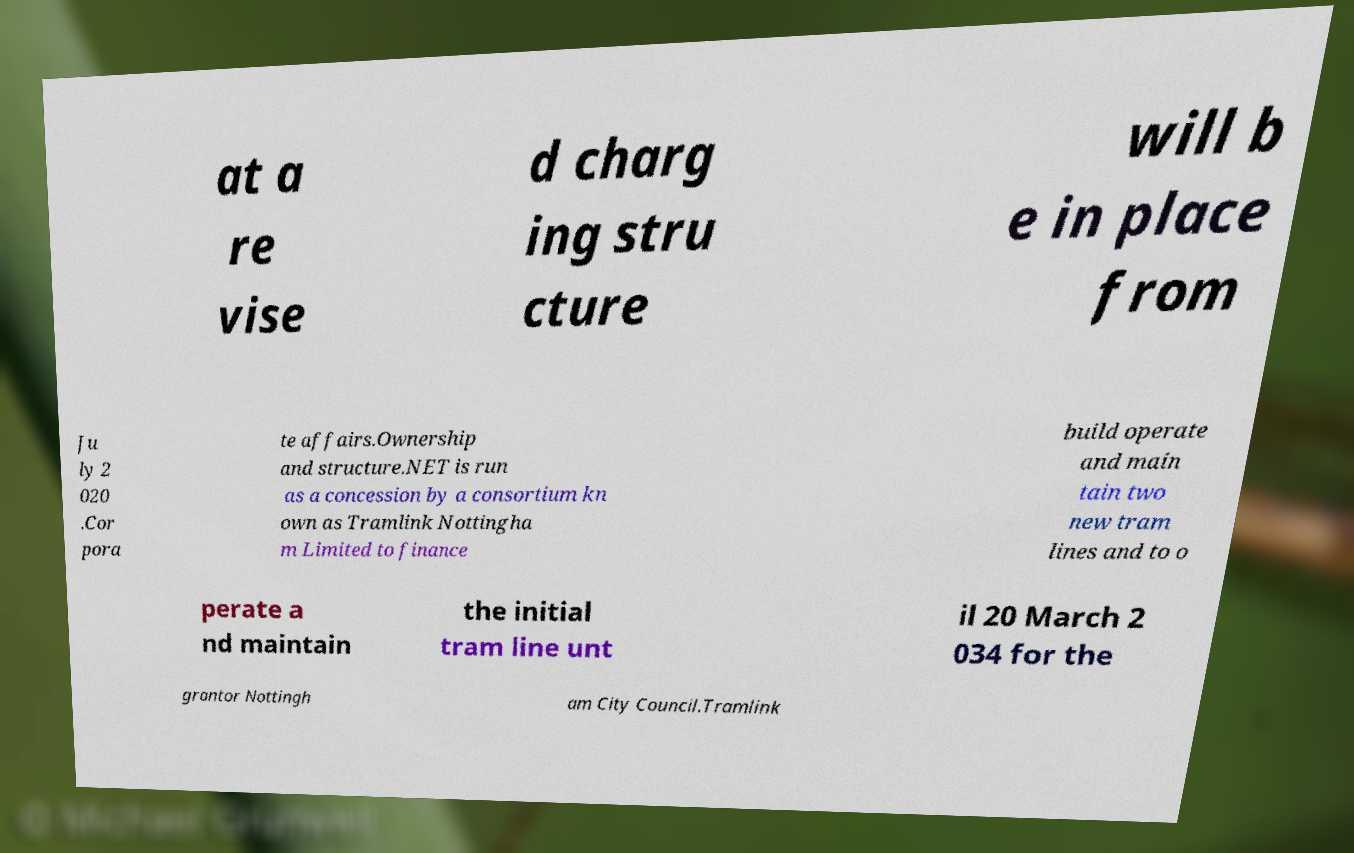Can you accurately transcribe the text from the provided image for me? at a re vise d charg ing stru cture will b e in place from Ju ly 2 020 .Cor pora te affairs.Ownership and structure.NET is run as a concession by a consortium kn own as Tramlink Nottingha m Limited to finance build operate and main tain two new tram lines and to o perate a nd maintain the initial tram line unt il 20 March 2 034 for the grantor Nottingh am City Council.Tramlink 